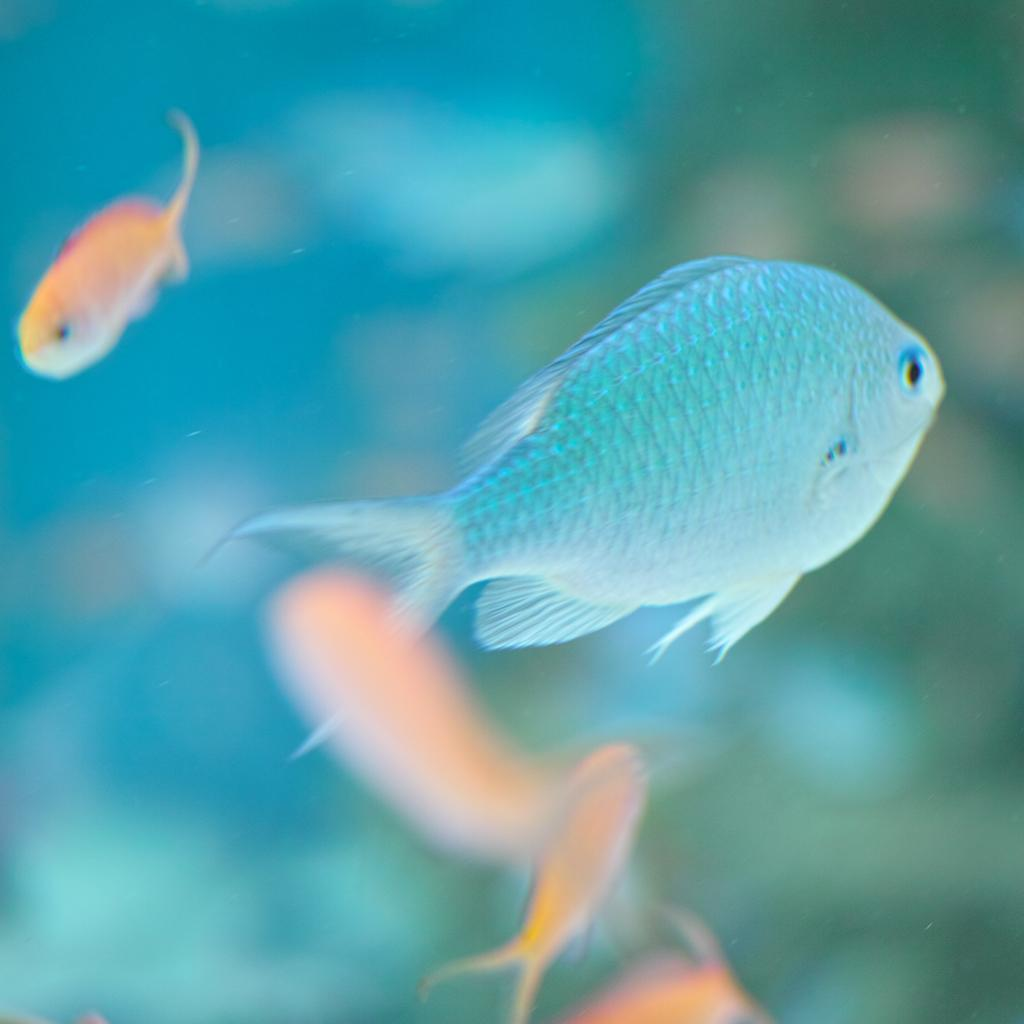What type of animals can be seen in the image? There are fishes in the image. Can you describe the background of the image? There are blurred things visible behind the fishes. What type of caption is present below the fishes in the image? There is no caption present below the fishes in the image. Can you hear a horn in the image? There is no auditory information in the image, so it is not possible to determine if a horn is present. 